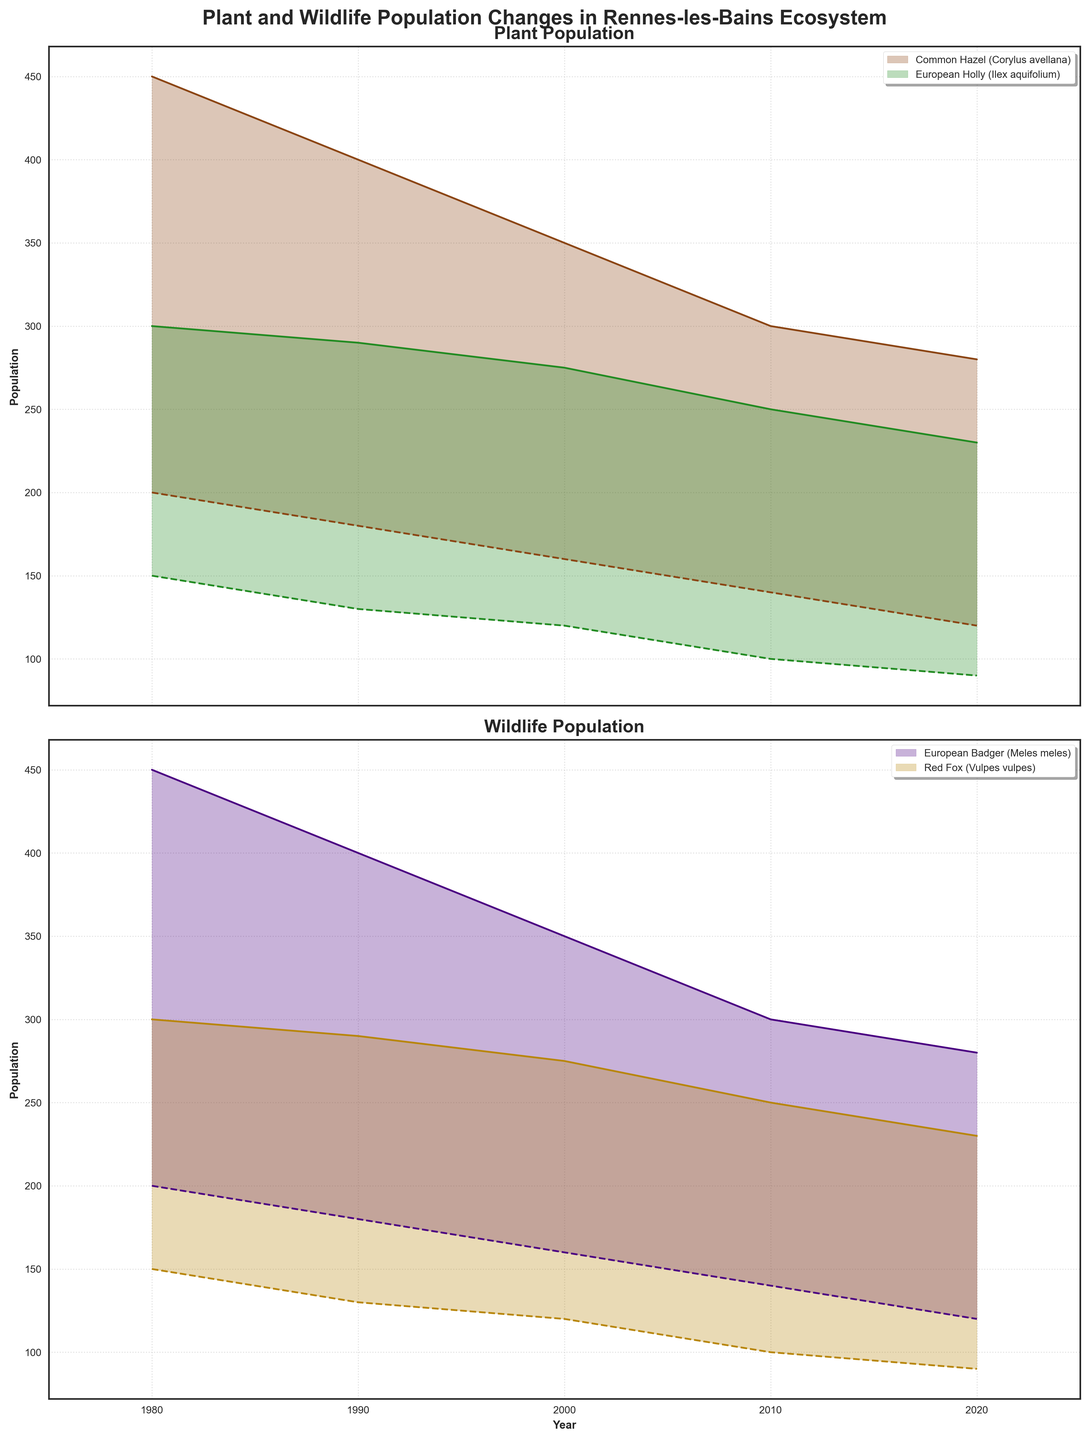What is the title of the figure? The title is located at the top and reads "Plant and Wildlife Population Changes in Rennes-les-Bains Ecosystem".
Answer: Plant and Wildlife Population Changes in Rennes-les-Bains Ecosystem How does the maximum population of Common Hazel (Corylus avellana) change from 1980 to 2020? We compare the values for the Max_Population of Common Hazel for 1980 and 2020 by looking at the top edge of the shaded area in the plant population chart. In 1980, it was 450, and in 2020, it decreased to 280.
Answer: It decreases Which plant type had a greater maximum population in 2000: Common Hazel (Corylus avellana) or European Holly (Ilex aquifolium)? In 2000, we observe the top level of the shaded ranges for both plants in the plant population chart. Common Hazel had a maximum population of 350, while European Holly had 275.
Answer: Common Hazel What is the difference between the minimum population of European Holly (Ilex aquifolium) in 1980 and 2020? The minimum population of European Holly in 1980 was 150, while in 2020 it was 90. Subtract 90 from 150 to find the difference.
Answer: 60 What is the trend for the European Badger (Meles meles) population over the decades? Observing the wildlife population chart, both the minimum and maximum populations of the European Badger steadily decrease from 1980 to 2020.
Answer: Decreasing In which year did the Red Fox (Vulpes vulpes) have its highest recorded maximum population, and what was it? We look for the highest point in the upper edge of the shaded area across all years for Red Fox in the wildlife population chart. In 1980, its maximum population was 300.
Answer: 1980, 300 Compare the minimum populations of European Badger (Meles meles) and Red Fox (Vulpes vulpes) in 2010. Which was higher? In the wildlife population chart for 2010, the lowest point of the shaded area for European Badger is at 140, while for Red Fox it is at 100. Hence, European Badger had the higher minimum population.
Answer: European Badger What is the average maximum population of Common Hazel (Corylus avellana) from 1980 to 2020? Sum the maximum populations for Common Hazel across all included decades (450 + 400 + 350 + 300 + 280) which equals 1780, then divide by the number of decades (5).
Answer: 356 Is there any consistent trend observed in the minimum population of European Holly (Ilex aquifolium) from 1980 to 2020? The minimum population of European Holly steadily decreases from 150 in 1980 to 90 in 2020, as seen by following the bottom edge of the shaded area in the plant population chart.
Answer: Decreasing 